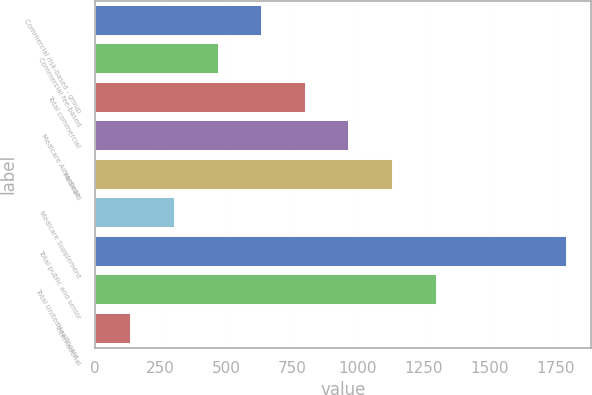Convert chart to OTSL. <chart><loc_0><loc_0><loc_500><loc_500><bar_chart><fcel>Commercial risk-based - group<fcel>Commercial fee-based<fcel>Total commercial<fcel>Medicare Advantage<fcel>Medicaid<fcel>Medicare Supplement<fcel>Total public and senior<fcel>Total UnitedHealthcare -<fcel>International<nl><fcel>636.5<fcel>471<fcel>802<fcel>967.5<fcel>1133<fcel>305.5<fcel>1795<fcel>1298.5<fcel>140<nl></chart> 